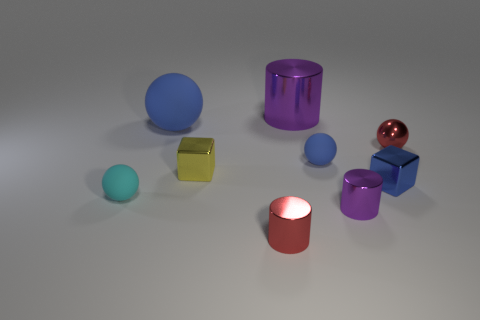Are there any other things that are the same size as the cyan thing?
Make the answer very short. Yes. Are there any blue things in front of the small blue shiny object?
Your answer should be compact. No. There is a tiny rubber thing to the right of the small cyan sphere on the left side of the red object left of the small blue metallic thing; what color is it?
Provide a succinct answer. Blue. There is a yellow object that is the same size as the cyan matte object; what shape is it?
Provide a succinct answer. Cube. Is the number of small red shiny spheres greater than the number of tiny purple metallic spheres?
Ensure brevity in your answer.  Yes. There is a large thing right of the large blue thing; is there a tiny blue sphere in front of it?
Keep it short and to the point. Yes. What is the color of the small metallic object that is the same shape as the small blue matte thing?
Ensure brevity in your answer.  Red. Are there any other things that are the same shape as the small purple object?
Give a very brief answer. Yes. There is a sphere that is the same material as the small blue block; what color is it?
Provide a succinct answer. Red. There is a tiny metal block that is to the right of the purple metal cylinder in front of the yellow metallic block; are there any tiny blue cubes that are behind it?
Offer a terse response. No. 